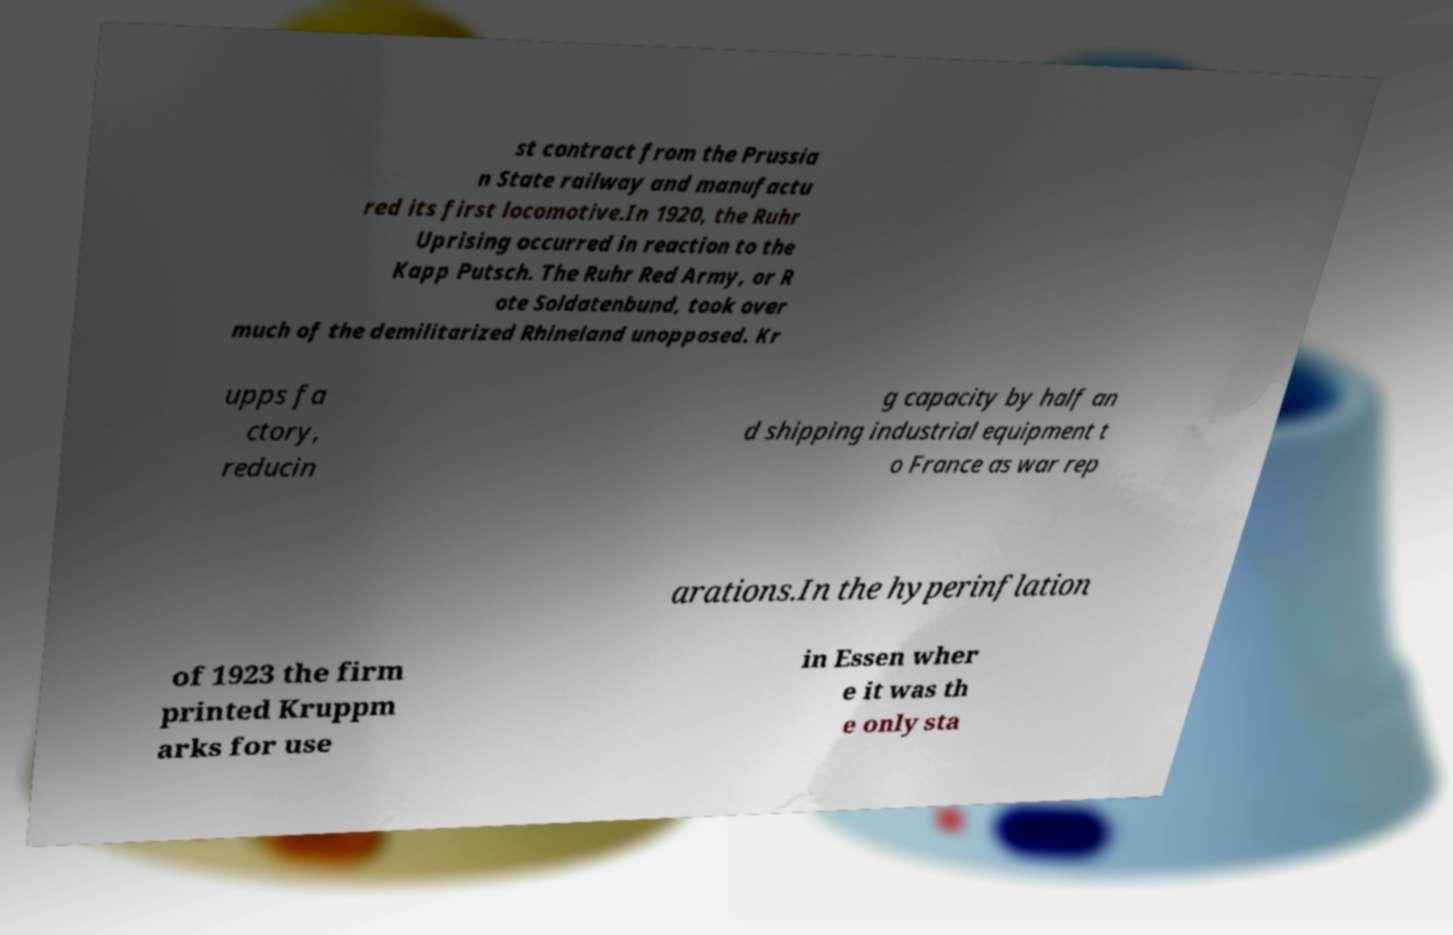Can you read and provide the text displayed in the image?This photo seems to have some interesting text. Can you extract and type it out for me? st contract from the Prussia n State railway and manufactu red its first locomotive.In 1920, the Ruhr Uprising occurred in reaction to the Kapp Putsch. The Ruhr Red Army, or R ote Soldatenbund, took over much of the demilitarized Rhineland unopposed. Kr upps fa ctory, reducin g capacity by half an d shipping industrial equipment t o France as war rep arations.In the hyperinflation of 1923 the firm printed Kruppm arks for use in Essen wher e it was th e only sta 